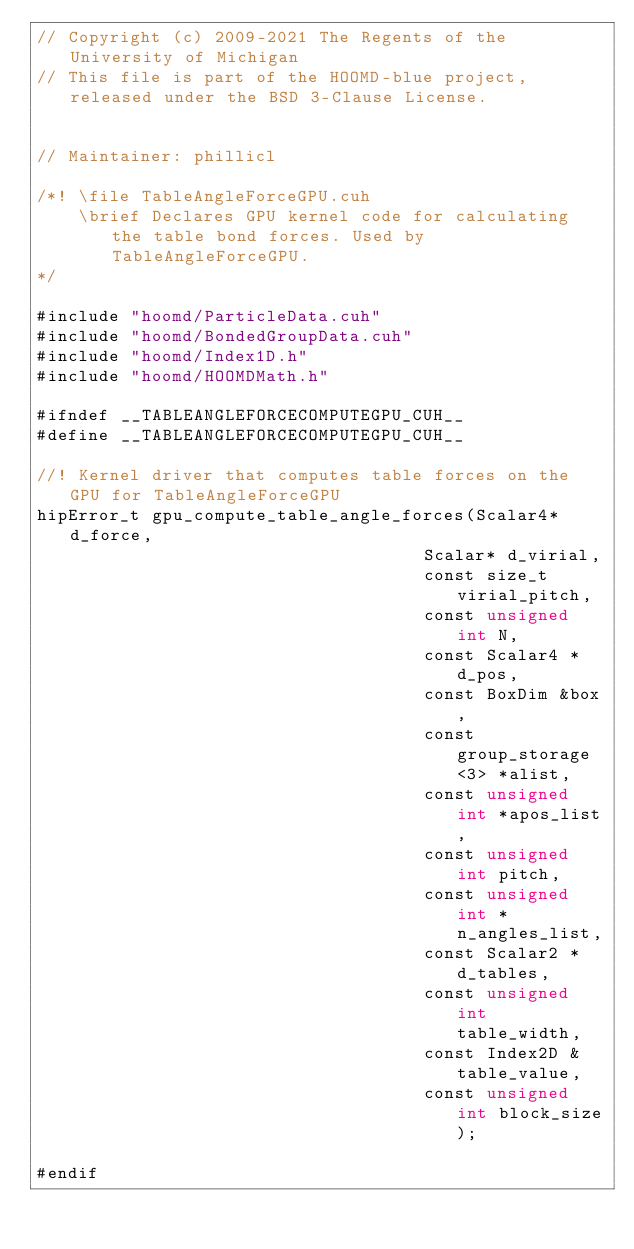Convert code to text. <code><loc_0><loc_0><loc_500><loc_500><_Cuda_>// Copyright (c) 2009-2021 The Regents of the University of Michigan
// This file is part of the HOOMD-blue project, released under the BSD 3-Clause License.


// Maintainer: phillicl

/*! \file TableAngleForceGPU.cuh
    \brief Declares GPU kernel code for calculating the table bond forces. Used by TableAngleForceGPU.
*/

#include "hoomd/ParticleData.cuh"
#include "hoomd/BondedGroupData.cuh"
#include "hoomd/Index1D.h"
#include "hoomd/HOOMDMath.h"

#ifndef __TABLEANGLEFORCECOMPUTEGPU_CUH__
#define __TABLEANGLEFORCECOMPUTEGPU_CUH__

//! Kernel driver that computes table forces on the GPU for TableAngleForceGPU
hipError_t gpu_compute_table_angle_forces(Scalar4* d_force,
                                     Scalar* d_virial,
                                     const size_t virial_pitch,
                                     const unsigned int N,
                                     const Scalar4 *d_pos,
                                     const BoxDim &box,
                                     const group_storage<3> *alist,
                                     const unsigned int *apos_list,
                                     const unsigned int pitch,
                                     const unsigned int *n_angles_list,
                                     const Scalar2 *d_tables,
                                     const unsigned int table_width,
                                     const Index2D &table_value,
                                     const unsigned int block_size);

#endif
</code> 